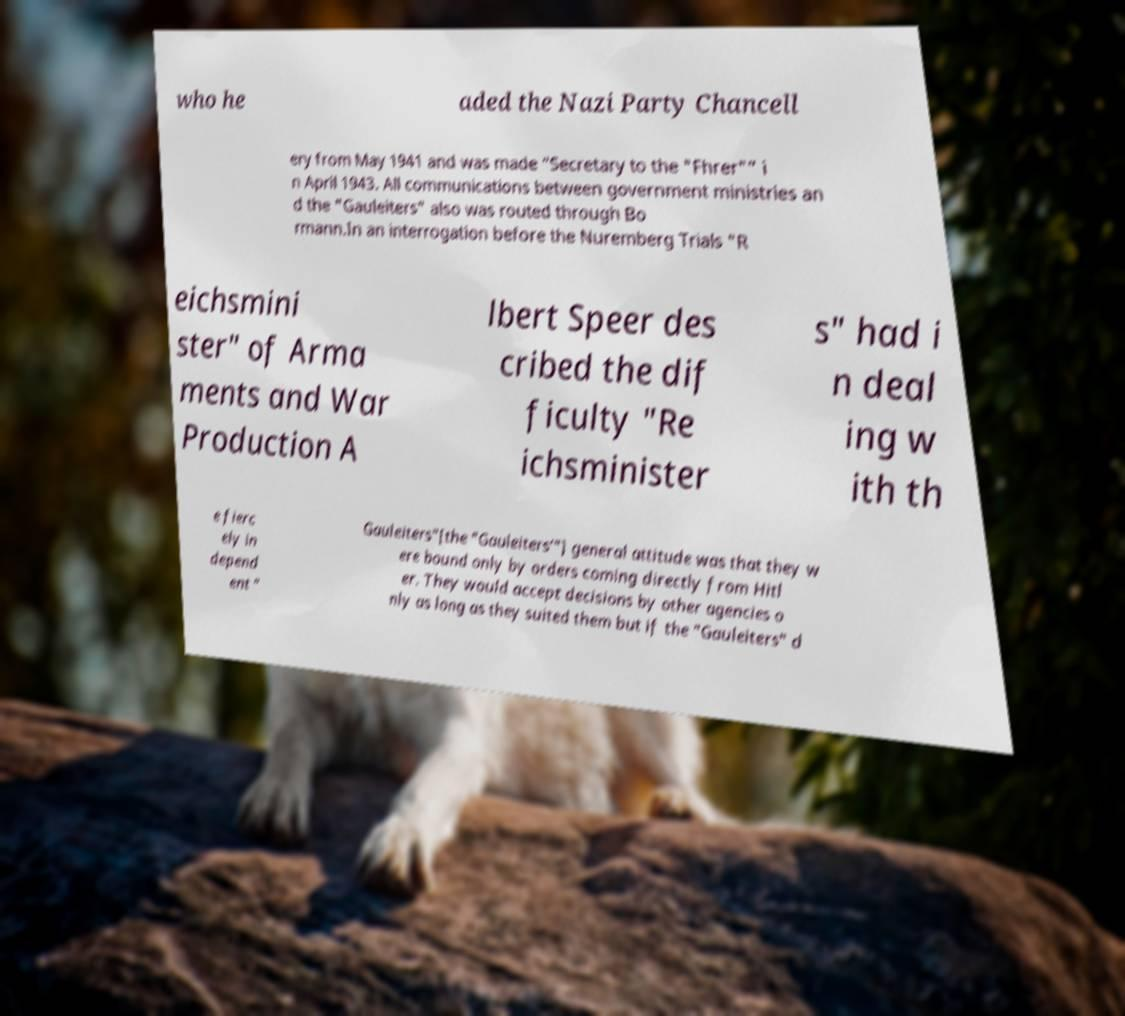What messages or text are displayed in this image? I need them in a readable, typed format. who he aded the Nazi Party Chancell ery from May 1941 and was made “Secretary to the "Fhrer"” i n April 1943. All communications between government ministries an d the "Gauleiters" also was routed through Bo rmann.In an interrogation before the Nuremberg Trials "R eichsmini ster" of Arma ments and War Production A lbert Speer des cribed the dif ficulty "Re ichsminister s" had i n deal ing w ith th e fierc ely in depend ent " Gauleiters"[the "Gauleiters’"] general attitude was that they w ere bound only by orders coming directly from Hitl er. They would accept decisions by other agencies o nly as long as they suited them but if the "Gauleiters" d 